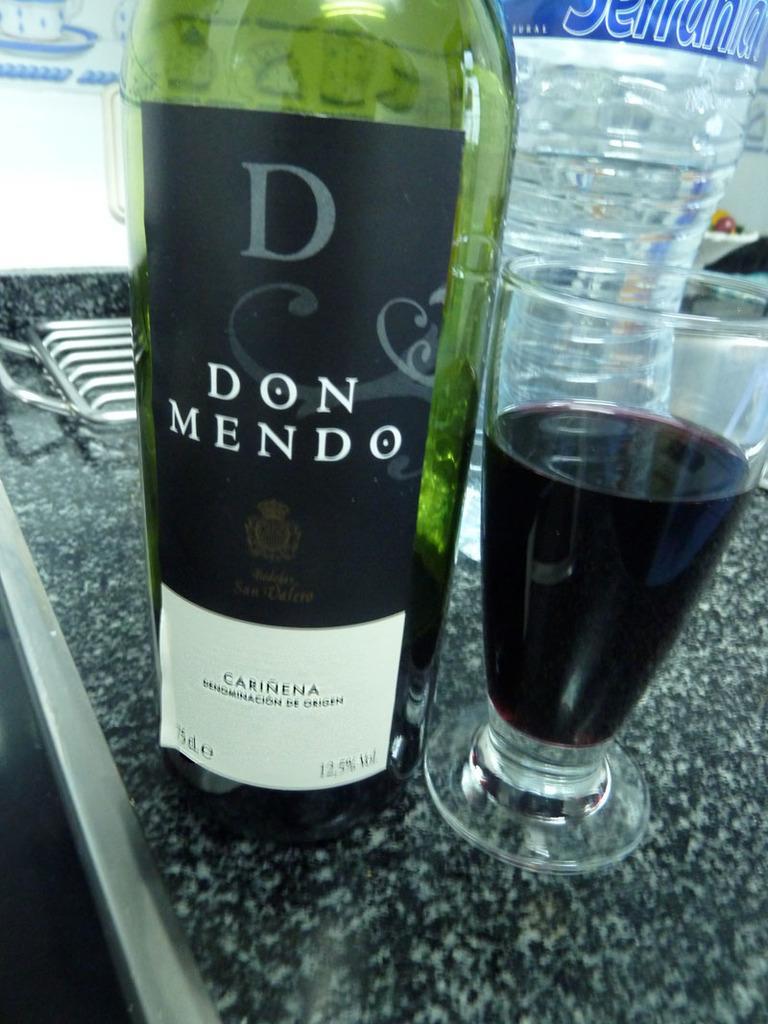Can you describe this image briefly? In this image we can see a wine bottle, a water bottle and a glass of wine. 